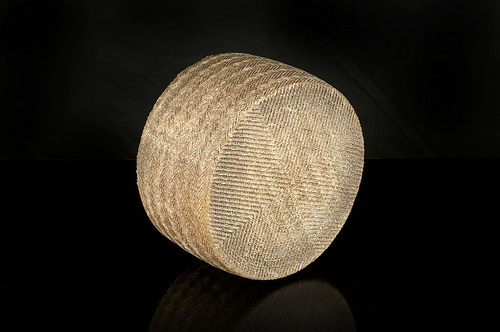<image>
Is there a cylinder in front of the car? No. The cylinder is not in front of the car. The spatial positioning shows a different relationship between these objects. 